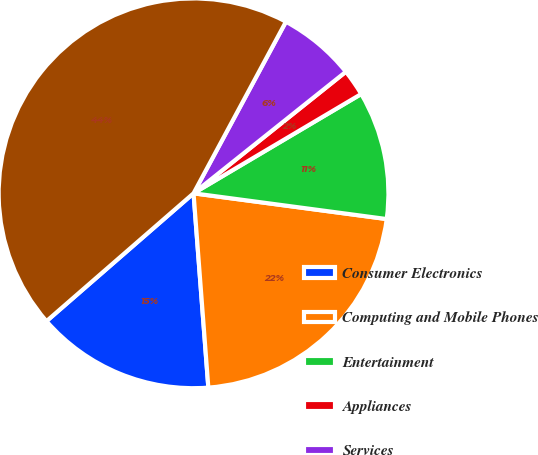Convert chart. <chart><loc_0><loc_0><loc_500><loc_500><pie_chart><fcel>Consumer Electronics<fcel>Computing and Mobile Phones<fcel>Entertainment<fcel>Appliances<fcel>Services<fcel>Total<nl><fcel>14.82%<fcel>21.68%<fcel>10.62%<fcel>2.21%<fcel>6.42%<fcel>44.25%<nl></chart> 